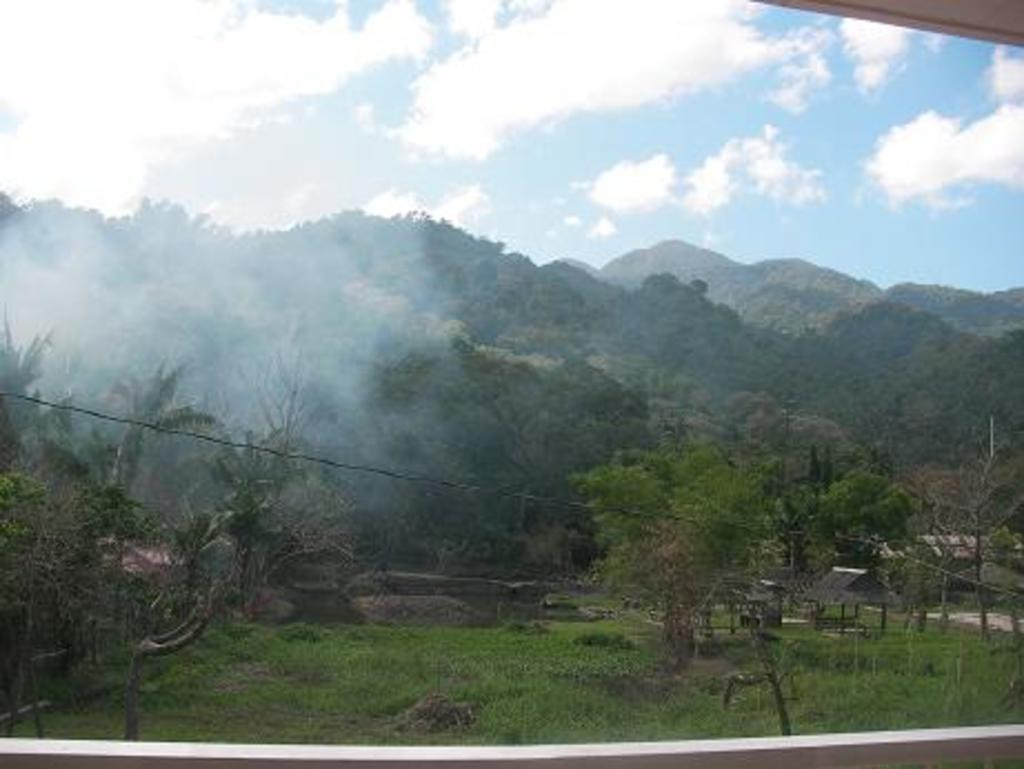What is the main subject in the center of the image? There is a glass element in the center of the image. What can be seen through the glass? Grass, plants, trees, huts, and wires are visible through the glass. What is visible in the background of the image? The sky, clouds, mountains, and trees are visible in the background of the image. What type of vessel is being used to express an opinion in the image? There is no vessel or expression of opinion present in the image. Can you tell me what type of quill is being used to write on the glass? There is no quill or writing on the glass in the image. 